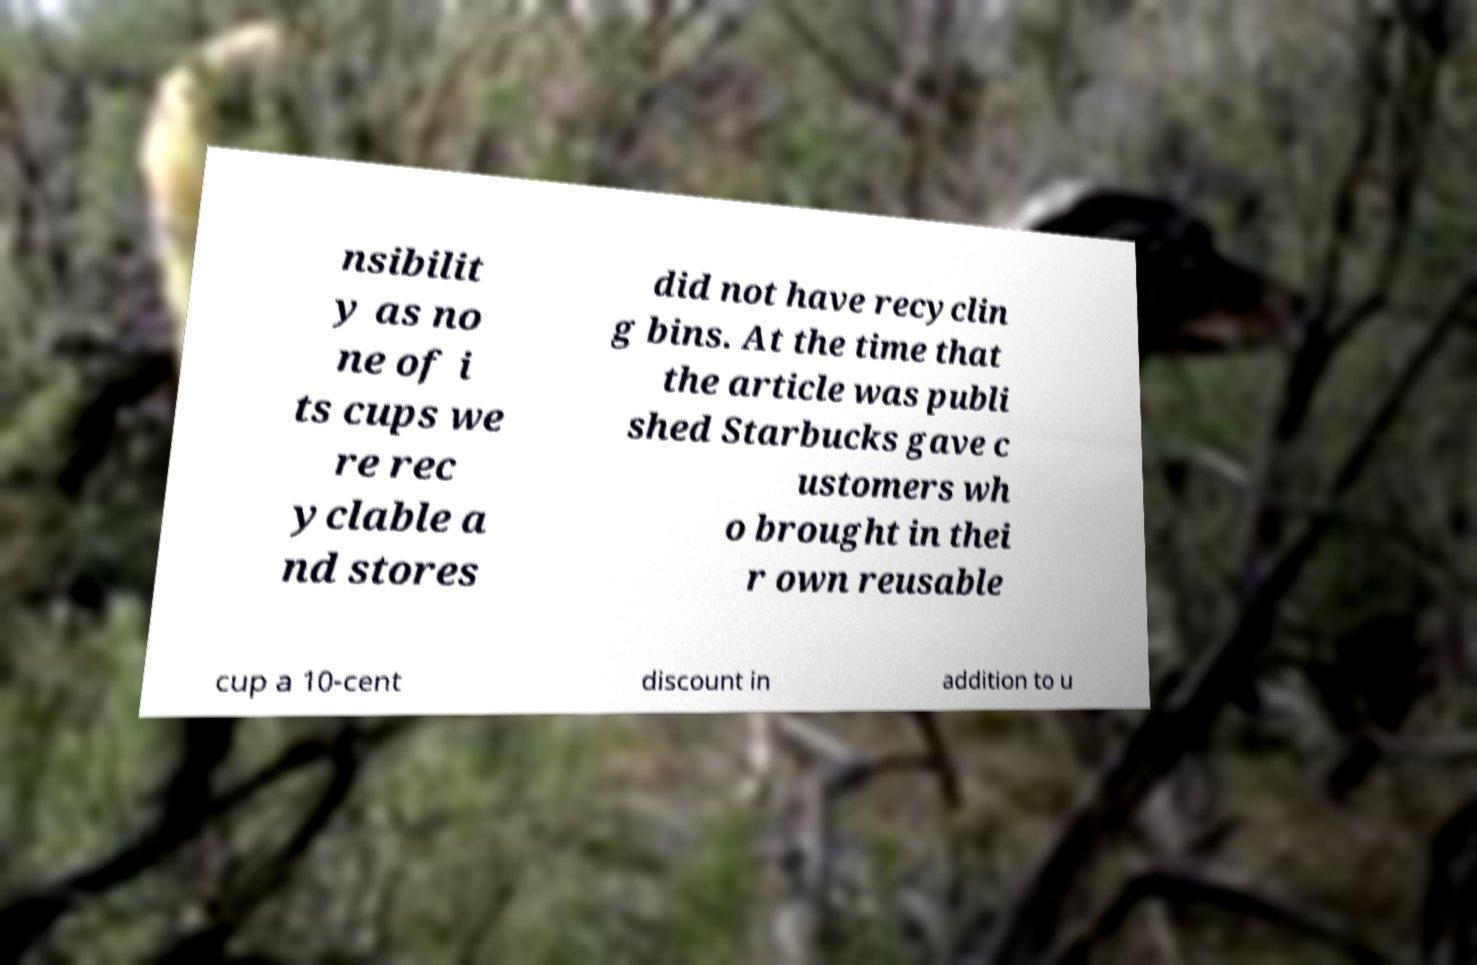I need the written content from this picture converted into text. Can you do that? nsibilit y as no ne of i ts cups we re rec yclable a nd stores did not have recyclin g bins. At the time that the article was publi shed Starbucks gave c ustomers wh o brought in thei r own reusable cup a 10-cent discount in addition to u 